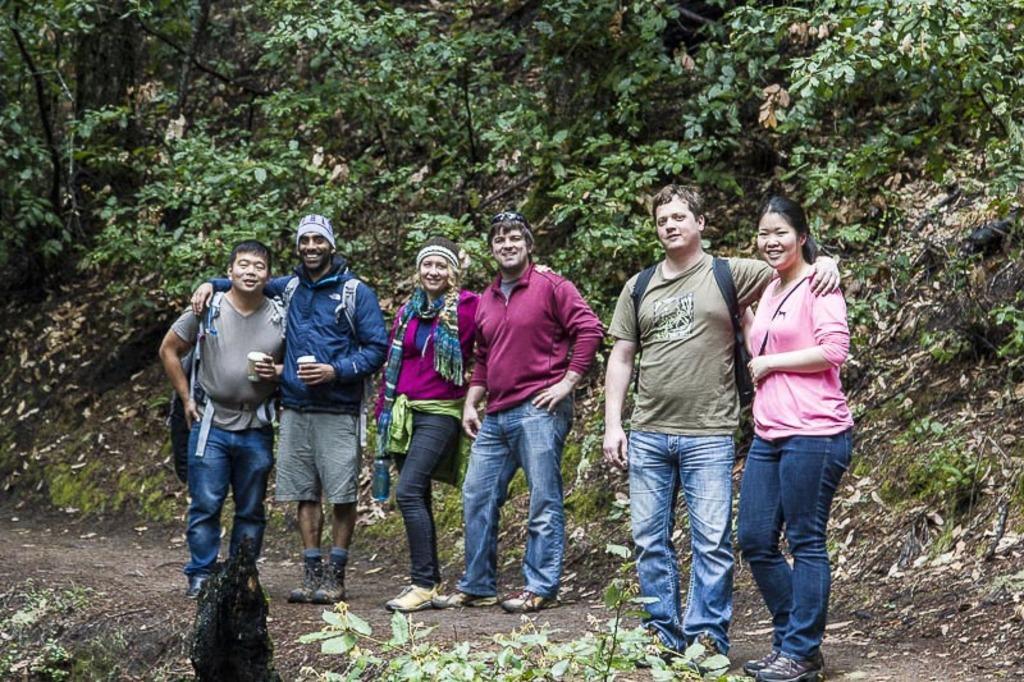How would you summarize this image in a sentence or two? In this picture there are group of people. Towards the left there are two man holding glasses and carrying bags. Beside them there are two people, one women and man wearing maroon jackets and woman is holding a bottle. Towards the right there are two persons, one man and a woman, man is wearing a green t-shirt and woman is wearing a pink jacket. In the background there are trees and plants. At the bottom there are plants. 